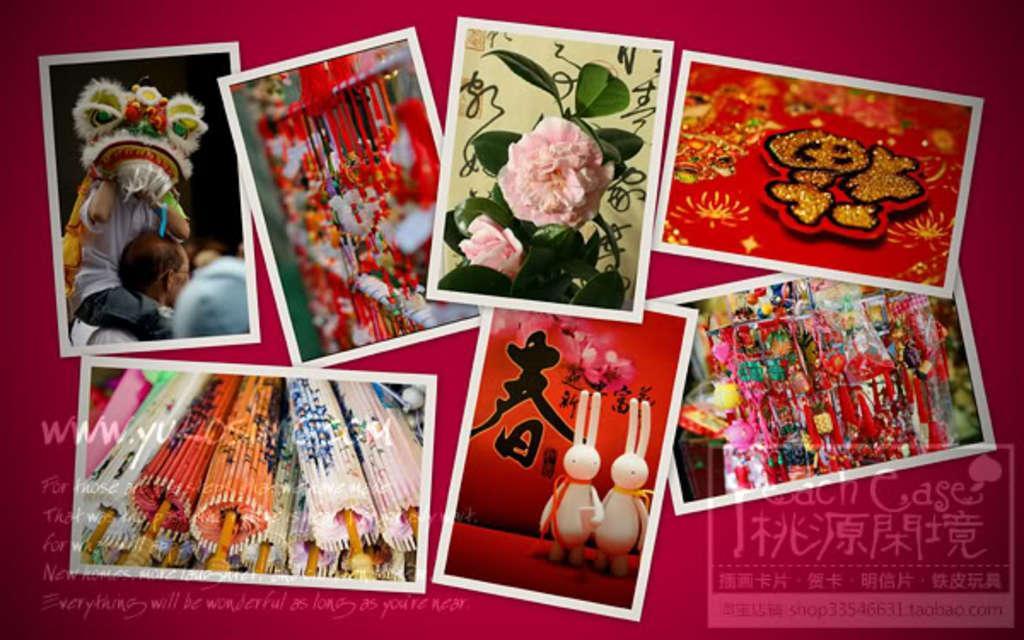In one or two sentences, can you explain what this image depicts? In this image we can see collage of some pictures in which we can see some flowers to plant, some people, ropes and some objects placed on the ground. At the bottom of the image we can see some text. 